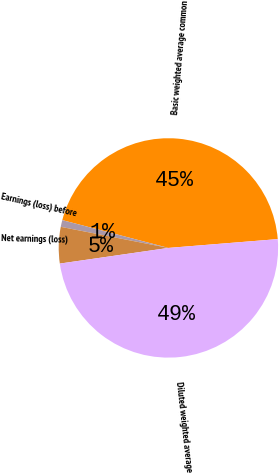Convert chart. <chart><loc_0><loc_0><loc_500><loc_500><pie_chart><fcel>Basic weighted average common<fcel>Earnings (loss) before<fcel>Net earnings (loss)<fcel>Diluted weighted average<nl><fcel>44.64%<fcel>1.0%<fcel>5.36%<fcel>49.0%<nl></chart> 